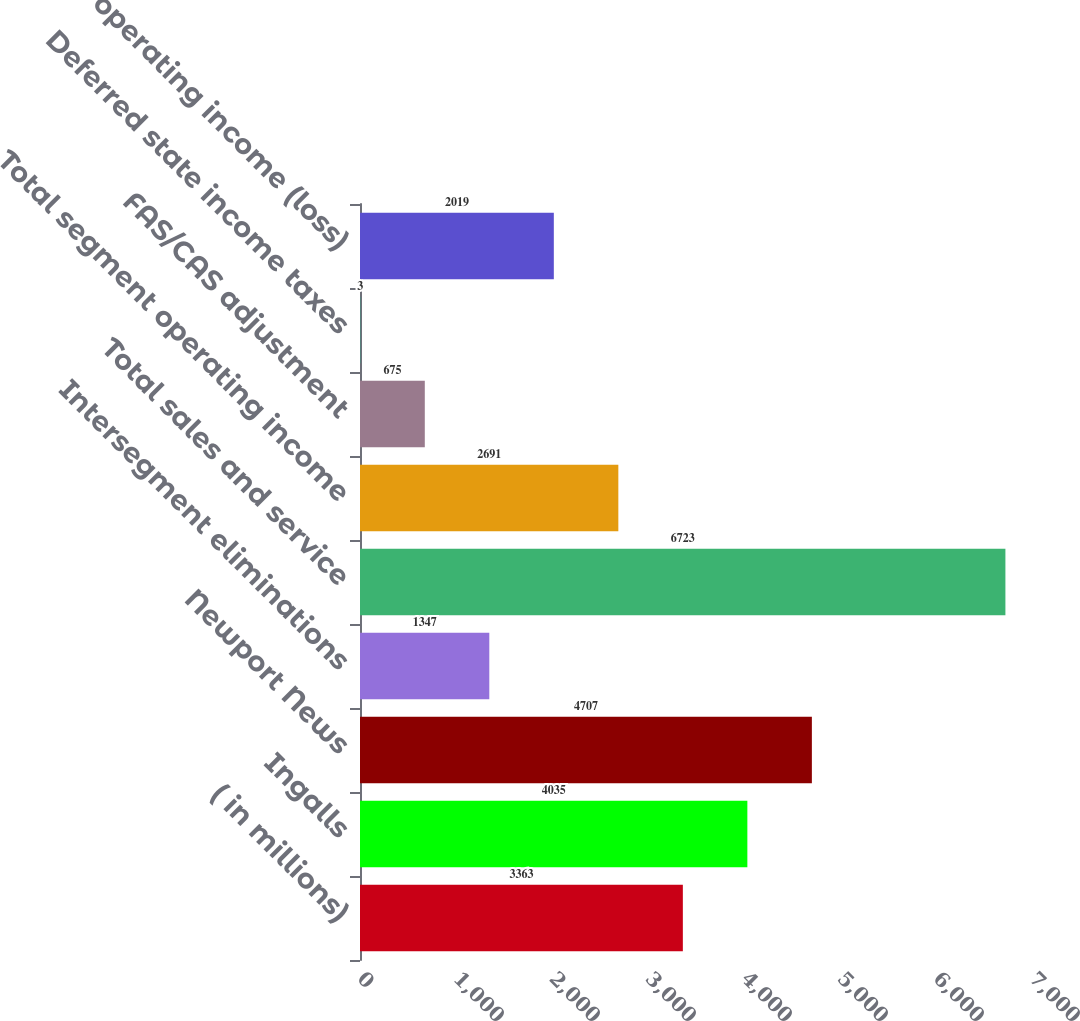<chart> <loc_0><loc_0><loc_500><loc_500><bar_chart><fcel>( in millions)<fcel>Ingalls<fcel>Newport News<fcel>Intersegment eliminations<fcel>Total sales and service<fcel>Total segment operating income<fcel>FAS/CAS adjustment<fcel>Deferred state income taxes<fcel>Total operating income (loss)<nl><fcel>3363<fcel>4035<fcel>4707<fcel>1347<fcel>6723<fcel>2691<fcel>675<fcel>3<fcel>2019<nl></chart> 